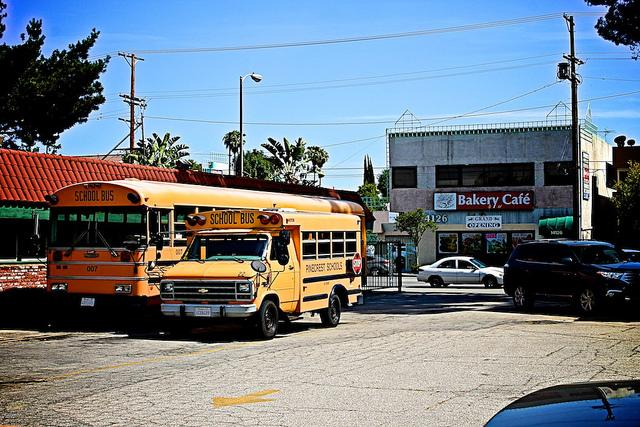When stopped what part of the smaller bus might most frequently pop out away from it's side? Please explain your reasoning. stop sign. The stop sign stopped the bus. 